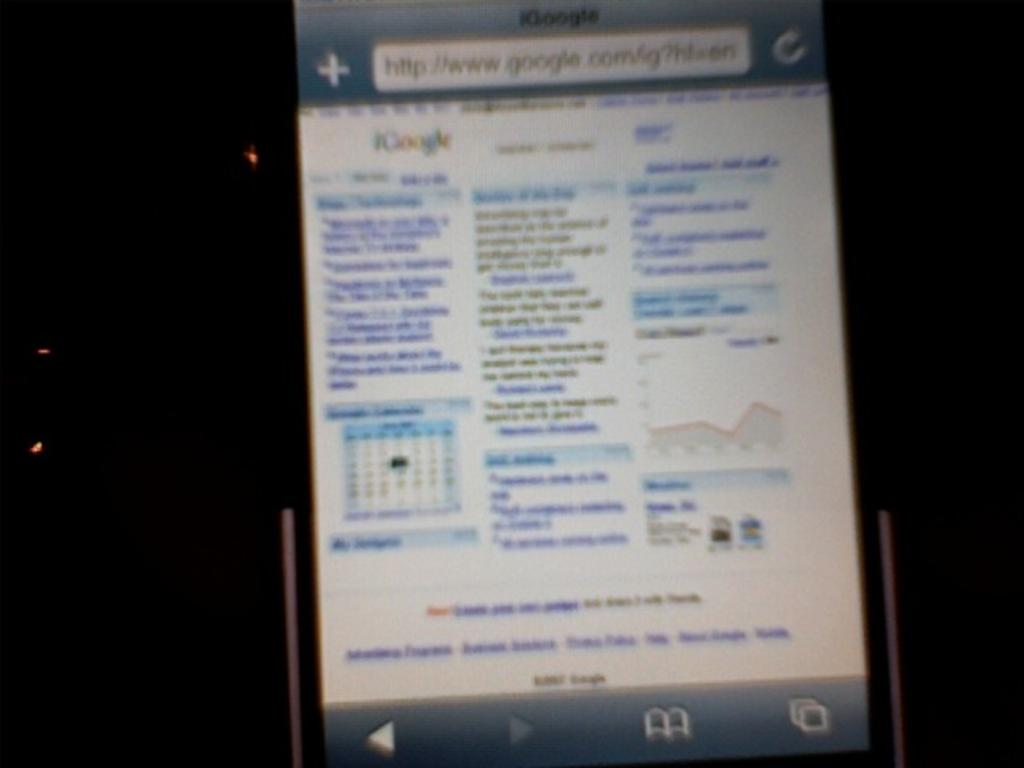<image>
Offer a succinct explanation of the picture presented. a cell phone on which someone is searching for something from google. 